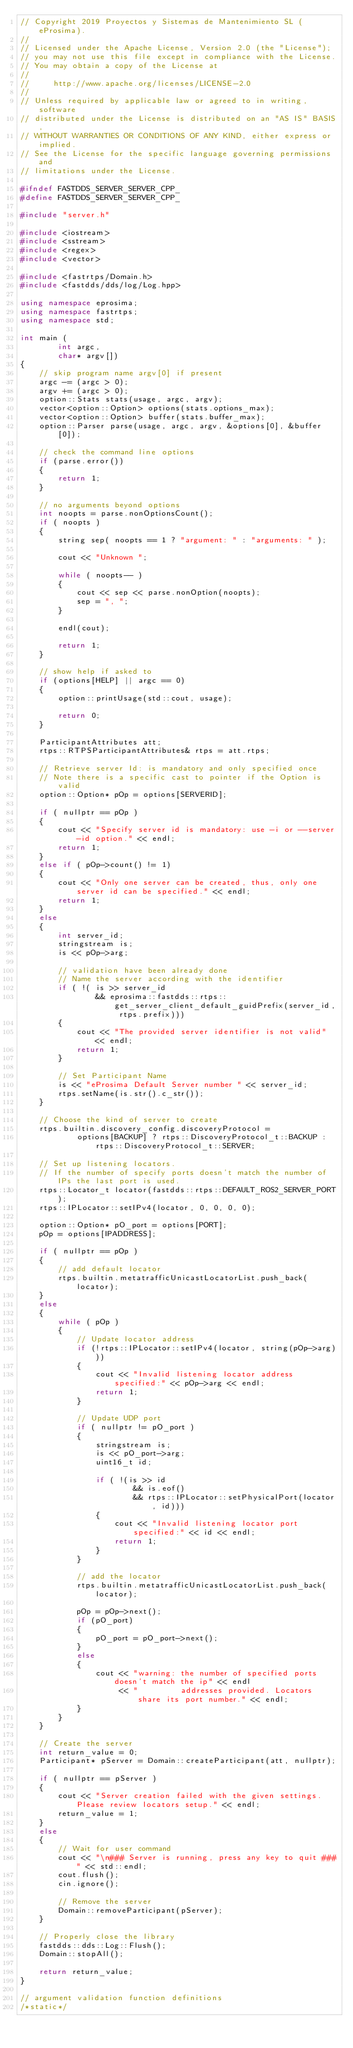Convert code to text. <code><loc_0><loc_0><loc_500><loc_500><_C++_>// Copyright 2019 Proyectos y Sistemas de Mantenimiento SL (eProsima).
//
// Licensed under the Apache License, Version 2.0 (the "License");
// you may not use this file except in compliance with the License.
// You may obtain a copy of the License at
//
//     http://www.apache.org/licenses/LICENSE-2.0
//
// Unless required by applicable law or agreed to in writing, software
// distributed under the License is distributed on an "AS IS" BASIS,
// WITHOUT WARRANTIES OR CONDITIONS OF ANY KIND, either express or implied.
// See the License for the specific language governing permissions and
// limitations under the License.

#ifndef FASTDDS_SERVER_SERVER_CPP_
#define FASTDDS_SERVER_SERVER_CPP_

#include "server.h"

#include <iostream>
#include <sstream>
#include <regex>
#include <vector>

#include <fastrtps/Domain.h>
#include <fastdds/dds/log/Log.hpp>

using namespace eprosima;
using namespace fastrtps;
using namespace std;

int main (
        int argc,
        char* argv[])
{
    // skip program name argv[0] if present
    argc -= (argc > 0);
    argv += (argc > 0);
    option::Stats stats(usage, argc, argv);
    vector<option::Option> options(stats.options_max);
    vector<option::Option> buffer(stats.buffer_max);
    option::Parser parse(usage, argc, argv, &options[0], &buffer[0]);

    // check the command line options
    if (parse.error())
    {
        return 1;
    }

    // no arguments beyond options
    int noopts = parse.nonOptionsCount();
    if ( noopts )
    {
        string sep( noopts == 1 ? "argument: " : "arguments: " );

        cout << "Unknown ";

        while ( noopts-- )
        {
            cout << sep << parse.nonOption(noopts);
            sep = ", ";
        }

        endl(cout);

        return 1;
    }

    // show help if asked to
    if (options[HELP] || argc == 0)
    {
        option::printUsage(std::cout, usage);

        return 0;
    }

    ParticipantAttributes att;
    rtps::RTPSParticipantAttributes& rtps = att.rtps;

    // Retrieve server Id: is mandatory and only specified once
    // Note there is a specific cast to pointer if the Option is valid
    option::Option* pOp = options[SERVERID];

    if ( nullptr == pOp )
    {
        cout << "Specify server id is mandatory: use -i or --server-id option." << endl;
        return 1;
    }
    else if ( pOp->count() != 1)
    {
        cout << "Only one server can be created, thus, only one server id can be specified." << endl;
        return 1;
    }
    else
    {
        int server_id;
        stringstream is;
        is << pOp->arg;

        // validation have been already done
        // Name the server according with the identifier
        if ( !( is >> server_id
                && eprosima::fastdds::rtps::get_server_client_default_guidPrefix(server_id, rtps.prefix)))
        {
            cout << "The provided server identifier is not valid" << endl;
            return 1;
        }

        // Set Participant Name
        is << "eProsima Default Server number " << server_id;
        rtps.setName(is.str().c_str());
    }

    // Choose the kind of server to create
    rtps.builtin.discovery_config.discoveryProtocol =
            options[BACKUP] ? rtps::DiscoveryProtocol_t::BACKUP : rtps::DiscoveryProtocol_t::SERVER;

    // Set up listening locators.
    // If the number of specify ports doesn't match the number of IPs the last port is used.
    rtps::Locator_t locator(fastdds::rtps::DEFAULT_ROS2_SERVER_PORT);
    rtps::IPLocator::setIPv4(locator, 0, 0, 0, 0);

    option::Option* pO_port = options[PORT];
    pOp = options[IPADDRESS];

    if ( nullptr == pOp )
    {
        // add default locator
        rtps.builtin.metatrafficUnicastLocatorList.push_back(locator);
    }
    else
    {
        while ( pOp )
        {
            // Update locator address
            if (!rtps::IPLocator::setIPv4(locator, string(pOp->arg)))
            {
                cout << "Invalid listening locator address specified:" << pOp->arg << endl;
                return 1;
            }

            // Update UDP port
            if ( nullptr != pO_port )
            {
                stringstream is;
                is << pO_port->arg;
                uint16_t id;

                if ( !(is >> id
                        && is.eof()
                        && rtps::IPLocator::setPhysicalPort(locator, id)))
                {
                    cout << "Invalid listening locator port specified:" << id << endl;
                    return 1;
                }
            }

            // add the locator
            rtps.builtin.metatrafficUnicastLocatorList.push_back(locator);

            pOp = pOp->next();
            if (pO_port)
            {
                pO_port = pO_port->next();
            }
            else
            {
                cout << "warning: the number of specified ports doesn't match the ip" << endl
                     << "         addresses provided. Locators share its port number." << endl;
            }
        }
    }

    // Create the server
    int return_value = 0;
    Participant* pServer = Domain::createParticipant(att, nullptr);

    if ( nullptr == pServer )
    {
        cout << "Server creation failed with the given settings. Please review locators setup." << endl;
        return_value = 1;
    }
    else
    {
        // Wait for user command
        cout << "\n### Server is running, press any key to quit ###" << std::endl;
        cout.flush();
        cin.ignore();

        // Remove the server
        Domain::removeParticipant(pServer);
    }

    // Properly close the library
    fastdds::dds::Log::Flush();
    Domain::stopAll();

    return return_value;
}

// argument validation function definitions
/*static*/</code> 